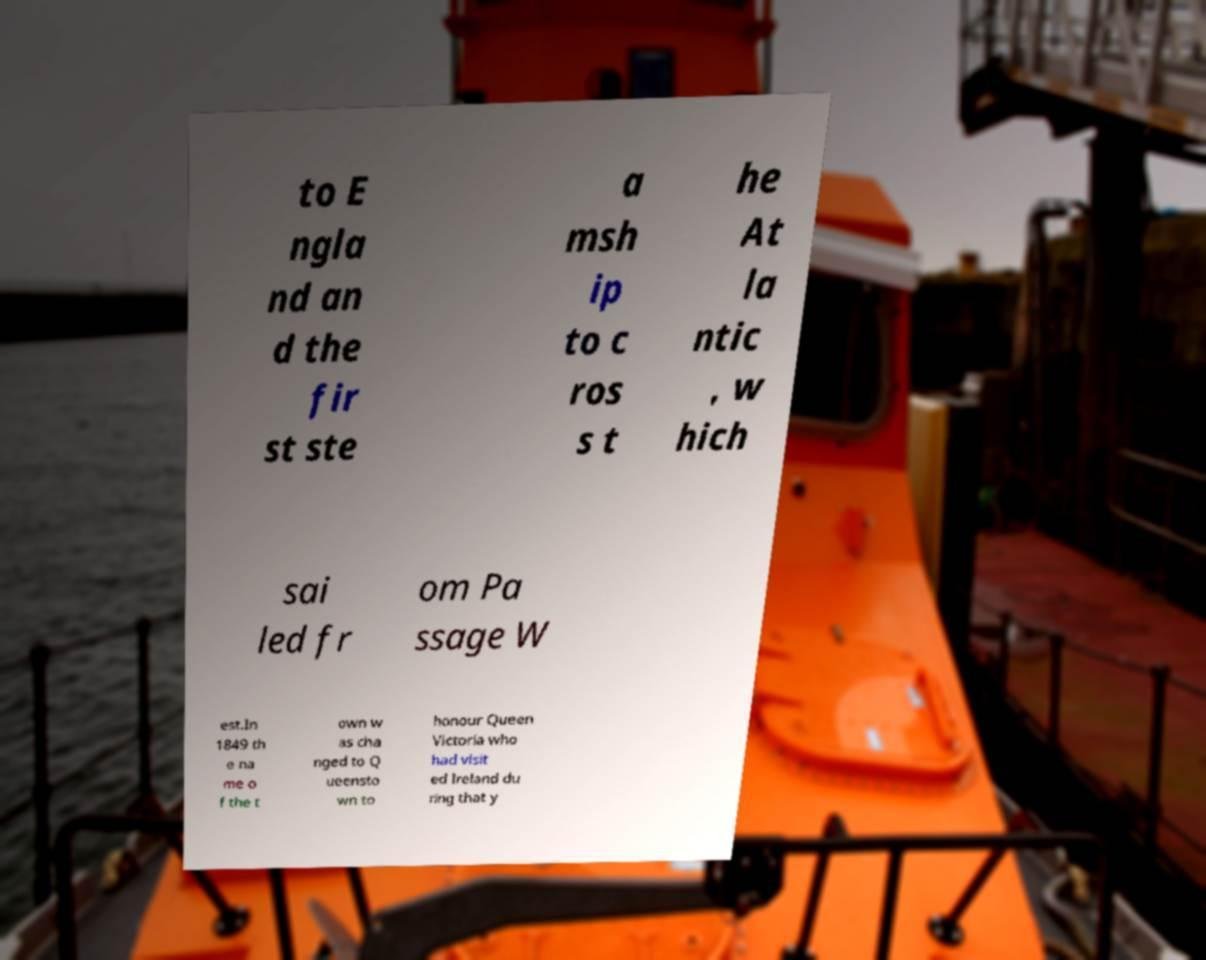Could you assist in decoding the text presented in this image and type it out clearly? to E ngla nd an d the fir st ste a msh ip to c ros s t he At la ntic , w hich sai led fr om Pa ssage W est.In 1849 th e na me o f the t own w as cha nged to Q ueensto wn to honour Queen Victoria who had visit ed Ireland du ring that y 